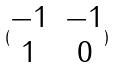<formula> <loc_0><loc_0><loc_500><loc_500>( \begin{matrix} - 1 & - 1 \\ 1 & 0 \end{matrix} )</formula> 